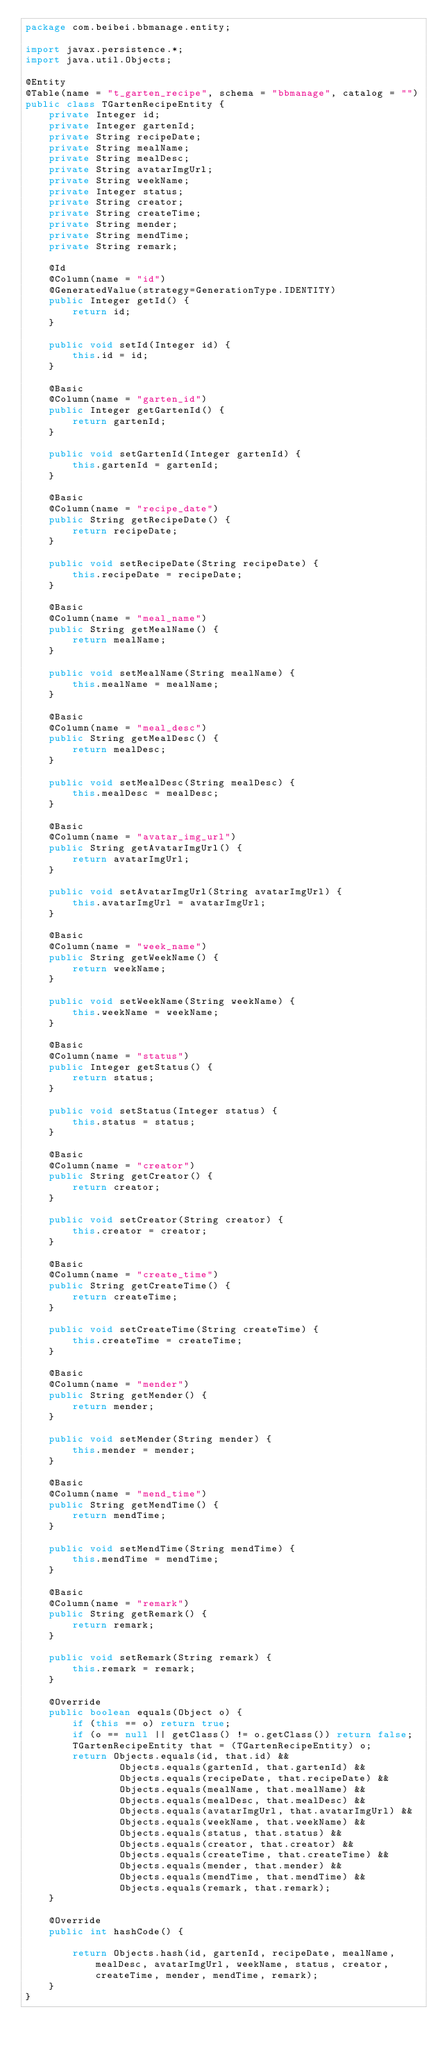<code> <loc_0><loc_0><loc_500><loc_500><_Java_>package com.beibei.bbmanage.entity;

import javax.persistence.*;
import java.util.Objects;

@Entity
@Table(name = "t_garten_recipe", schema = "bbmanage", catalog = "")
public class TGartenRecipeEntity {
    private Integer id;
    private Integer gartenId;
    private String recipeDate;
    private String mealName;
    private String mealDesc;
    private String avatarImgUrl;
    private String weekName;
    private Integer status;
    private String creator;
    private String createTime;
    private String mender;
    private String mendTime;
    private String remark;

    @Id
    @Column(name = "id")
    @GeneratedValue(strategy=GenerationType.IDENTITY)
    public Integer getId() {
        return id;
    }

    public void setId(Integer id) {
        this.id = id;
    }

    @Basic
    @Column(name = "garten_id")
    public Integer getGartenId() {
        return gartenId;
    }

    public void setGartenId(Integer gartenId) {
        this.gartenId = gartenId;
    }

    @Basic
    @Column(name = "recipe_date")
    public String getRecipeDate() {
        return recipeDate;
    }

    public void setRecipeDate(String recipeDate) {
        this.recipeDate = recipeDate;
    }

    @Basic
    @Column(name = "meal_name")
    public String getMealName() {
        return mealName;
    }

    public void setMealName(String mealName) {
        this.mealName = mealName;
    }

    @Basic
    @Column(name = "meal_desc")
    public String getMealDesc() {
        return mealDesc;
    }

    public void setMealDesc(String mealDesc) {
        this.mealDesc = mealDesc;
    }

    @Basic
    @Column(name = "avatar_img_url")
    public String getAvatarImgUrl() {
        return avatarImgUrl;
    }

    public void setAvatarImgUrl(String avatarImgUrl) {
        this.avatarImgUrl = avatarImgUrl;
    }

    @Basic
    @Column(name = "week_name")
    public String getWeekName() {
        return weekName;
    }

    public void setWeekName(String weekName) {
        this.weekName = weekName;
    }

    @Basic
    @Column(name = "status")
    public Integer getStatus() {
        return status;
    }

    public void setStatus(Integer status) {
        this.status = status;
    }

    @Basic
    @Column(name = "creator")
    public String getCreator() {
        return creator;
    }

    public void setCreator(String creator) {
        this.creator = creator;
    }

    @Basic
    @Column(name = "create_time")
    public String getCreateTime() {
        return createTime;
    }

    public void setCreateTime(String createTime) {
        this.createTime = createTime;
    }

    @Basic
    @Column(name = "mender")
    public String getMender() {
        return mender;
    }

    public void setMender(String mender) {
        this.mender = mender;
    }

    @Basic
    @Column(name = "mend_time")
    public String getMendTime() {
        return mendTime;
    }

    public void setMendTime(String mendTime) {
        this.mendTime = mendTime;
    }

    @Basic
    @Column(name = "remark")
    public String getRemark() {
        return remark;
    }

    public void setRemark(String remark) {
        this.remark = remark;
    }

    @Override
    public boolean equals(Object o) {
        if (this == o) return true;
        if (o == null || getClass() != o.getClass()) return false;
        TGartenRecipeEntity that = (TGartenRecipeEntity) o;
        return Objects.equals(id, that.id) &&
                Objects.equals(gartenId, that.gartenId) &&
                Objects.equals(recipeDate, that.recipeDate) &&
                Objects.equals(mealName, that.mealName) &&
                Objects.equals(mealDesc, that.mealDesc) &&
                Objects.equals(avatarImgUrl, that.avatarImgUrl) &&
                Objects.equals(weekName, that.weekName) &&
                Objects.equals(status, that.status) &&
                Objects.equals(creator, that.creator) &&
                Objects.equals(createTime, that.createTime) &&
                Objects.equals(mender, that.mender) &&
                Objects.equals(mendTime, that.mendTime) &&
                Objects.equals(remark, that.remark);
    }

    @Override
    public int hashCode() {

        return Objects.hash(id, gartenId, recipeDate, mealName, mealDesc, avatarImgUrl, weekName, status, creator, createTime, mender, mendTime, remark);
    }
}
</code> 